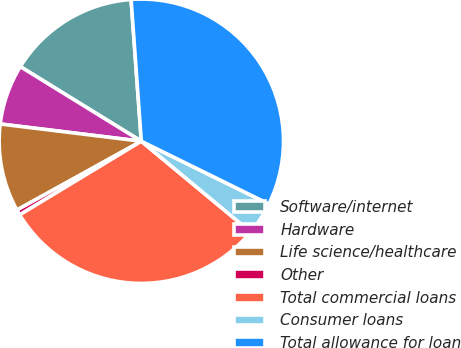Convert chart. <chart><loc_0><loc_0><loc_500><loc_500><pie_chart><fcel>Software/internet<fcel>Hardware<fcel>Life science/healthcare<fcel>Other<fcel>Total commercial loans<fcel>Consumer loans<fcel>Total allowance for loan<nl><fcel>15.06%<fcel>6.86%<fcel>9.98%<fcel>0.62%<fcel>30.32%<fcel>3.74%<fcel>33.43%<nl></chart> 